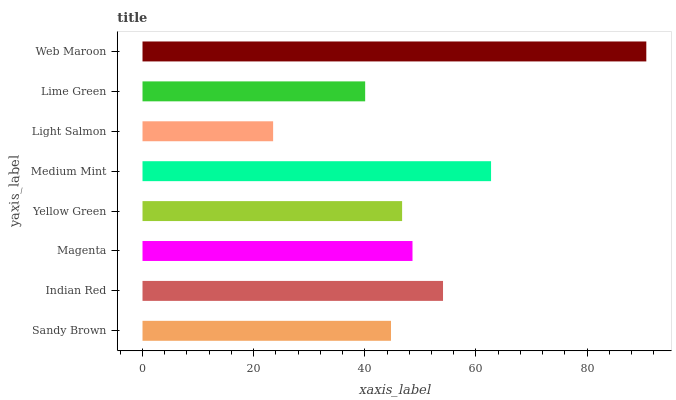Is Light Salmon the minimum?
Answer yes or no. Yes. Is Web Maroon the maximum?
Answer yes or no. Yes. Is Indian Red the minimum?
Answer yes or no. No. Is Indian Red the maximum?
Answer yes or no. No. Is Indian Red greater than Sandy Brown?
Answer yes or no. Yes. Is Sandy Brown less than Indian Red?
Answer yes or no. Yes. Is Sandy Brown greater than Indian Red?
Answer yes or no. No. Is Indian Red less than Sandy Brown?
Answer yes or no. No. Is Magenta the high median?
Answer yes or no. Yes. Is Yellow Green the low median?
Answer yes or no. Yes. Is Yellow Green the high median?
Answer yes or no. No. Is Light Salmon the low median?
Answer yes or no. No. 